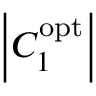Convert formula to latex. <formula><loc_0><loc_0><loc_500><loc_500>\left | { C _ { 1 } ^ { o p t } } \right |</formula> 